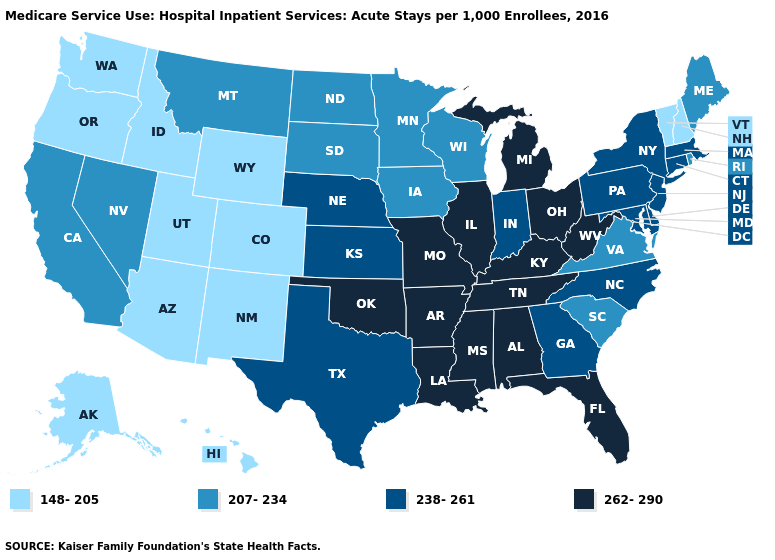Which states have the lowest value in the USA?
Write a very short answer. Alaska, Arizona, Colorado, Hawaii, Idaho, New Hampshire, New Mexico, Oregon, Utah, Vermont, Washington, Wyoming. How many symbols are there in the legend?
Short answer required. 4. Does the first symbol in the legend represent the smallest category?
Write a very short answer. Yes. Name the states that have a value in the range 207-234?
Write a very short answer. California, Iowa, Maine, Minnesota, Montana, Nevada, North Dakota, Rhode Island, South Carolina, South Dakota, Virginia, Wisconsin. What is the value of Arizona?
Be succinct. 148-205. What is the lowest value in states that border Florida?
Keep it brief. 238-261. What is the value of Maryland?
Concise answer only. 238-261. What is the value of Florida?
Keep it brief. 262-290. What is the value of New Hampshire?
Write a very short answer. 148-205. Does Minnesota have the lowest value in the USA?
Concise answer only. No. What is the lowest value in states that border Mississippi?
Write a very short answer. 262-290. What is the highest value in the USA?
Be succinct. 262-290. What is the highest value in the South ?
Be succinct. 262-290. What is the value of Nebraska?
Answer briefly. 238-261. Name the states that have a value in the range 238-261?
Be succinct. Connecticut, Delaware, Georgia, Indiana, Kansas, Maryland, Massachusetts, Nebraska, New Jersey, New York, North Carolina, Pennsylvania, Texas. 